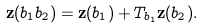Convert formula to latex. <formula><loc_0><loc_0><loc_500><loc_500>\mathbf z ( b _ { 1 } b _ { 2 } ) = \mathbf z ( b _ { 1 } ) + T _ { b _ { 1 } } \mathbf z ( b _ { 2 } ) .</formula> 